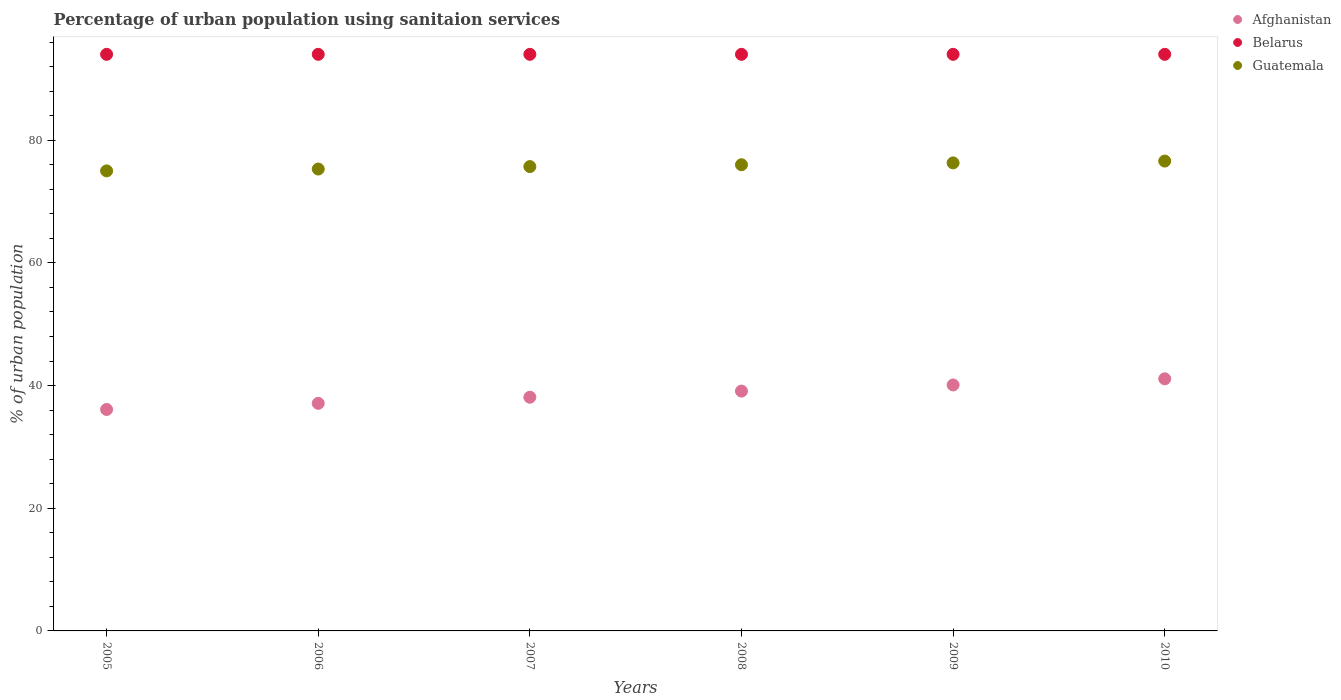How many different coloured dotlines are there?
Make the answer very short. 3. Is the number of dotlines equal to the number of legend labels?
Provide a short and direct response. Yes. What is the percentage of urban population using sanitaion services in Belarus in 2007?
Your response must be concise. 94. Across all years, what is the maximum percentage of urban population using sanitaion services in Guatemala?
Ensure brevity in your answer.  76.6. Across all years, what is the minimum percentage of urban population using sanitaion services in Belarus?
Make the answer very short. 94. What is the total percentage of urban population using sanitaion services in Belarus in the graph?
Give a very brief answer. 564. What is the difference between the percentage of urban population using sanitaion services in Belarus in 2007 and that in 2008?
Ensure brevity in your answer.  0. What is the difference between the percentage of urban population using sanitaion services in Belarus in 2006 and the percentage of urban population using sanitaion services in Afghanistan in 2010?
Make the answer very short. 52.9. What is the average percentage of urban population using sanitaion services in Afghanistan per year?
Ensure brevity in your answer.  38.6. In the year 2008, what is the difference between the percentage of urban population using sanitaion services in Belarus and percentage of urban population using sanitaion services in Afghanistan?
Ensure brevity in your answer.  54.9. In how many years, is the percentage of urban population using sanitaion services in Belarus greater than 92 %?
Keep it short and to the point. 6. What is the ratio of the percentage of urban population using sanitaion services in Belarus in 2009 to that in 2010?
Your response must be concise. 1. Is the percentage of urban population using sanitaion services in Guatemala in 2008 less than that in 2009?
Make the answer very short. Yes. What is the difference between the highest and the second highest percentage of urban population using sanitaion services in Guatemala?
Provide a short and direct response. 0.3. What is the difference between the highest and the lowest percentage of urban population using sanitaion services in Belarus?
Your response must be concise. 0. Is the sum of the percentage of urban population using sanitaion services in Belarus in 2005 and 2006 greater than the maximum percentage of urban population using sanitaion services in Afghanistan across all years?
Your answer should be very brief. Yes. Is it the case that in every year, the sum of the percentage of urban population using sanitaion services in Guatemala and percentage of urban population using sanitaion services in Belarus  is greater than the percentage of urban population using sanitaion services in Afghanistan?
Make the answer very short. Yes. Is the percentage of urban population using sanitaion services in Afghanistan strictly greater than the percentage of urban population using sanitaion services in Belarus over the years?
Offer a terse response. No. How many years are there in the graph?
Ensure brevity in your answer.  6. What is the difference between two consecutive major ticks on the Y-axis?
Provide a succinct answer. 20. Are the values on the major ticks of Y-axis written in scientific E-notation?
Your answer should be very brief. No. Does the graph contain grids?
Give a very brief answer. No. What is the title of the graph?
Offer a terse response. Percentage of urban population using sanitaion services. Does "Tonga" appear as one of the legend labels in the graph?
Offer a very short reply. No. What is the label or title of the X-axis?
Provide a short and direct response. Years. What is the label or title of the Y-axis?
Ensure brevity in your answer.  % of urban population. What is the % of urban population in Afghanistan in 2005?
Your answer should be compact. 36.1. What is the % of urban population of Belarus in 2005?
Offer a very short reply. 94. What is the % of urban population of Guatemala in 2005?
Make the answer very short. 75. What is the % of urban population in Afghanistan in 2006?
Your response must be concise. 37.1. What is the % of urban population in Belarus in 2006?
Ensure brevity in your answer.  94. What is the % of urban population of Guatemala in 2006?
Provide a short and direct response. 75.3. What is the % of urban population in Afghanistan in 2007?
Ensure brevity in your answer.  38.1. What is the % of urban population of Belarus in 2007?
Make the answer very short. 94. What is the % of urban population of Guatemala in 2007?
Offer a very short reply. 75.7. What is the % of urban population of Afghanistan in 2008?
Offer a terse response. 39.1. What is the % of urban population of Belarus in 2008?
Offer a very short reply. 94. What is the % of urban population in Guatemala in 2008?
Provide a succinct answer. 76. What is the % of urban population of Afghanistan in 2009?
Your answer should be very brief. 40.1. What is the % of urban population of Belarus in 2009?
Make the answer very short. 94. What is the % of urban population in Guatemala in 2009?
Your answer should be compact. 76.3. What is the % of urban population of Afghanistan in 2010?
Your response must be concise. 41.1. What is the % of urban population in Belarus in 2010?
Keep it short and to the point. 94. What is the % of urban population of Guatemala in 2010?
Your answer should be very brief. 76.6. Across all years, what is the maximum % of urban population of Afghanistan?
Give a very brief answer. 41.1. Across all years, what is the maximum % of urban population of Belarus?
Provide a short and direct response. 94. Across all years, what is the maximum % of urban population of Guatemala?
Ensure brevity in your answer.  76.6. Across all years, what is the minimum % of urban population of Afghanistan?
Provide a succinct answer. 36.1. Across all years, what is the minimum % of urban population in Belarus?
Provide a short and direct response. 94. Across all years, what is the minimum % of urban population in Guatemala?
Your answer should be compact. 75. What is the total % of urban population of Afghanistan in the graph?
Your answer should be compact. 231.6. What is the total % of urban population of Belarus in the graph?
Provide a succinct answer. 564. What is the total % of urban population in Guatemala in the graph?
Provide a succinct answer. 454.9. What is the difference between the % of urban population of Belarus in 2005 and that in 2006?
Ensure brevity in your answer.  0. What is the difference between the % of urban population in Guatemala in 2005 and that in 2006?
Your answer should be very brief. -0.3. What is the difference between the % of urban population in Afghanistan in 2005 and that in 2007?
Provide a short and direct response. -2. What is the difference between the % of urban population in Belarus in 2005 and that in 2007?
Offer a very short reply. 0. What is the difference between the % of urban population in Afghanistan in 2005 and that in 2008?
Offer a very short reply. -3. What is the difference between the % of urban population in Belarus in 2005 and that in 2008?
Offer a terse response. 0. What is the difference between the % of urban population of Guatemala in 2005 and that in 2008?
Offer a terse response. -1. What is the difference between the % of urban population in Guatemala in 2005 and that in 2009?
Offer a terse response. -1.3. What is the difference between the % of urban population of Afghanistan in 2005 and that in 2010?
Provide a short and direct response. -5. What is the difference between the % of urban population in Guatemala in 2005 and that in 2010?
Make the answer very short. -1.6. What is the difference between the % of urban population of Afghanistan in 2006 and that in 2007?
Offer a terse response. -1. What is the difference between the % of urban population in Belarus in 2006 and that in 2008?
Your answer should be compact. 0. What is the difference between the % of urban population in Afghanistan in 2006 and that in 2009?
Your response must be concise. -3. What is the difference between the % of urban population of Belarus in 2006 and that in 2009?
Your response must be concise. 0. What is the difference between the % of urban population in Guatemala in 2006 and that in 2009?
Offer a terse response. -1. What is the difference between the % of urban population of Afghanistan in 2006 and that in 2010?
Offer a terse response. -4. What is the difference between the % of urban population in Belarus in 2006 and that in 2010?
Provide a succinct answer. 0. What is the difference between the % of urban population of Belarus in 2007 and that in 2008?
Your answer should be compact. 0. What is the difference between the % of urban population in Belarus in 2007 and that in 2009?
Provide a succinct answer. 0. What is the difference between the % of urban population in Guatemala in 2007 and that in 2009?
Provide a succinct answer. -0.6. What is the difference between the % of urban population of Afghanistan in 2007 and that in 2010?
Your answer should be compact. -3. What is the difference between the % of urban population of Belarus in 2007 and that in 2010?
Provide a succinct answer. 0. What is the difference between the % of urban population in Belarus in 2008 and that in 2009?
Offer a terse response. 0. What is the difference between the % of urban population in Guatemala in 2008 and that in 2009?
Offer a very short reply. -0.3. What is the difference between the % of urban population of Belarus in 2008 and that in 2010?
Provide a short and direct response. 0. What is the difference between the % of urban population of Afghanistan in 2005 and the % of urban population of Belarus in 2006?
Give a very brief answer. -57.9. What is the difference between the % of urban population of Afghanistan in 2005 and the % of urban population of Guatemala in 2006?
Your answer should be compact. -39.2. What is the difference between the % of urban population of Belarus in 2005 and the % of urban population of Guatemala in 2006?
Provide a short and direct response. 18.7. What is the difference between the % of urban population in Afghanistan in 2005 and the % of urban population in Belarus in 2007?
Your answer should be very brief. -57.9. What is the difference between the % of urban population of Afghanistan in 2005 and the % of urban population of Guatemala in 2007?
Provide a short and direct response. -39.6. What is the difference between the % of urban population of Afghanistan in 2005 and the % of urban population of Belarus in 2008?
Your answer should be very brief. -57.9. What is the difference between the % of urban population of Afghanistan in 2005 and the % of urban population of Guatemala in 2008?
Provide a short and direct response. -39.9. What is the difference between the % of urban population of Belarus in 2005 and the % of urban population of Guatemala in 2008?
Give a very brief answer. 18. What is the difference between the % of urban population of Afghanistan in 2005 and the % of urban population of Belarus in 2009?
Provide a succinct answer. -57.9. What is the difference between the % of urban population in Afghanistan in 2005 and the % of urban population in Guatemala in 2009?
Provide a short and direct response. -40.2. What is the difference between the % of urban population of Belarus in 2005 and the % of urban population of Guatemala in 2009?
Give a very brief answer. 17.7. What is the difference between the % of urban population of Afghanistan in 2005 and the % of urban population of Belarus in 2010?
Ensure brevity in your answer.  -57.9. What is the difference between the % of urban population of Afghanistan in 2005 and the % of urban population of Guatemala in 2010?
Offer a terse response. -40.5. What is the difference between the % of urban population in Belarus in 2005 and the % of urban population in Guatemala in 2010?
Give a very brief answer. 17.4. What is the difference between the % of urban population of Afghanistan in 2006 and the % of urban population of Belarus in 2007?
Your response must be concise. -56.9. What is the difference between the % of urban population of Afghanistan in 2006 and the % of urban population of Guatemala in 2007?
Make the answer very short. -38.6. What is the difference between the % of urban population in Belarus in 2006 and the % of urban population in Guatemala in 2007?
Your response must be concise. 18.3. What is the difference between the % of urban population in Afghanistan in 2006 and the % of urban population in Belarus in 2008?
Give a very brief answer. -56.9. What is the difference between the % of urban population of Afghanistan in 2006 and the % of urban population of Guatemala in 2008?
Keep it short and to the point. -38.9. What is the difference between the % of urban population of Belarus in 2006 and the % of urban population of Guatemala in 2008?
Your response must be concise. 18. What is the difference between the % of urban population of Afghanistan in 2006 and the % of urban population of Belarus in 2009?
Provide a succinct answer. -56.9. What is the difference between the % of urban population in Afghanistan in 2006 and the % of urban population in Guatemala in 2009?
Offer a terse response. -39.2. What is the difference between the % of urban population of Belarus in 2006 and the % of urban population of Guatemala in 2009?
Your response must be concise. 17.7. What is the difference between the % of urban population in Afghanistan in 2006 and the % of urban population in Belarus in 2010?
Your answer should be very brief. -56.9. What is the difference between the % of urban population of Afghanistan in 2006 and the % of urban population of Guatemala in 2010?
Your answer should be very brief. -39.5. What is the difference between the % of urban population in Belarus in 2006 and the % of urban population in Guatemala in 2010?
Provide a succinct answer. 17.4. What is the difference between the % of urban population in Afghanistan in 2007 and the % of urban population in Belarus in 2008?
Provide a short and direct response. -55.9. What is the difference between the % of urban population in Afghanistan in 2007 and the % of urban population in Guatemala in 2008?
Your answer should be compact. -37.9. What is the difference between the % of urban population of Belarus in 2007 and the % of urban population of Guatemala in 2008?
Ensure brevity in your answer.  18. What is the difference between the % of urban population in Afghanistan in 2007 and the % of urban population in Belarus in 2009?
Provide a succinct answer. -55.9. What is the difference between the % of urban population in Afghanistan in 2007 and the % of urban population in Guatemala in 2009?
Ensure brevity in your answer.  -38.2. What is the difference between the % of urban population of Afghanistan in 2007 and the % of urban population of Belarus in 2010?
Offer a very short reply. -55.9. What is the difference between the % of urban population in Afghanistan in 2007 and the % of urban population in Guatemala in 2010?
Make the answer very short. -38.5. What is the difference between the % of urban population in Afghanistan in 2008 and the % of urban population in Belarus in 2009?
Your response must be concise. -54.9. What is the difference between the % of urban population of Afghanistan in 2008 and the % of urban population of Guatemala in 2009?
Ensure brevity in your answer.  -37.2. What is the difference between the % of urban population in Belarus in 2008 and the % of urban population in Guatemala in 2009?
Make the answer very short. 17.7. What is the difference between the % of urban population of Afghanistan in 2008 and the % of urban population of Belarus in 2010?
Offer a terse response. -54.9. What is the difference between the % of urban population of Afghanistan in 2008 and the % of urban population of Guatemala in 2010?
Your answer should be compact. -37.5. What is the difference between the % of urban population of Afghanistan in 2009 and the % of urban population of Belarus in 2010?
Offer a very short reply. -53.9. What is the difference between the % of urban population in Afghanistan in 2009 and the % of urban population in Guatemala in 2010?
Provide a succinct answer. -36.5. What is the difference between the % of urban population in Belarus in 2009 and the % of urban population in Guatemala in 2010?
Make the answer very short. 17.4. What is the average % of urban population of Afghanistan per year?
Offer a very short reply. 38.6. What is the average % of urban population in Belarus per year?
Your answer should be very brief. 94. What is the average % of urban population of Guatemala per year?
Give a very brief answer. 75.82. In the year 2005, what is the difference between the % of urban population of Afghanistan and % of urban population of Belarus?
Provide a short and direct response. -57.9. In the year 2005, what is the difference between the % of urban population in Afghanistan and % of urban population in Guatemala?
Your response must be concise. -38.9. In the year 2005, what is the difference between the % of urban population of Belarus and % of urban population of Guatemala?
Provide a short and direct response. 19. In the year 2006, what is the difference between the % of urban population in Afghanistan and % of urban population in Belarus?
Your answer should be very brief. -56.9. In the year 2006, what is the difference between the % of urban population of Afghanistan and % of urban population of Guatemala?
Make the answer very short. -38.2. In the year 2007, what is the difference between the % of urban population of Afghanistan and % of urban population of Belarus?
Your response must be concise. -55.9. In the year 2007, what is the difference between the % of urban population of Afghanistan and % of urban population of Guatemala?
Your response must be concise. -37.6. In the year 2007, what is the difference between the % of urban population in Belarus and % of urban population in Guatemala?
Your answer should be compact. 18.3. In the year 2008, what is the difference between the % of urban population of Afghanistan and % of urban population of Belarus?
Your answer should be compact. -54.9. In the year 2008, what is the difference between the % of urban population in Afghanistan and % of urban population in Guatemala?
Your answer should be compact. -36.9. In the year 2009, what is the difference between the % of urban population in Afghanistan and % of urban population in Belarus?
Offer a very short reply. -53.9. In the year 2009, what is the difference between the % of urban population in Afghanistan and % of urban population in Guatemala?
Provide a succinct answer. -36.2. In the year 2010, what is the difference between the % of urban population of Afghanistan and % of urban population of Belarus?
Provide a short and direct response. -52.9. In the year 2010, what is the difference between the % of urban population in Afghanistan and % of urban population in Guatemala?
Offer a terse response. -35.5. In the year 2010, what is the difference between the % of urban population of Belarus and % of urban population of Guatemala?
Your answer should be compact. 17.4. What is the ratio of the % of urban population in Belarus in 2005 to that in 2006?
Your answer should be very brief. 1. What is the ratio of the % of urban population in Guatemala in 2005 to that in 2006?
Your response must be concise. 1. What is the ratio of the % of urban population in Afghanistan in 2005 to that in 2007?
Ensure brevity in your answer.  0.95. What is the ratio of the % of urban population in Belarus in 2005 to that in 2007?
Provide a succinct answer. 1. What is the ratio of the % of urban population of Afghanistan in 2005 to that in 2008?
Your answer should be very brief. 0.92. What is the ratio of the % of urban population in Guatemala in 2005 to that in 2008?
Offer a terse response. 0.99. What is the ratio of the % of urban population in Afghanistan in 2005 to that in 2009?
Provide a succinct answer. 0.9. What is the ratio of the % of urban population in Belarus in 2005 to that in 2009?
Your answer should be compact. 1. What is the ratio of the % of urban population in Afghanistan in 2005 to that in 2010?
Offer a terse response. 0.88. What is the ratio of the % of urban population in Guatemala in 2005 to that in 2010?
Your answer should be very brief. 0.98. What is the ratio of the % of urban population of Afghanistan in 2006 to that in 2007?
Give a very brief answer. 0.97. What is the ratio of the % of urban population of Belarus in 2006 to that in 2007?
Provide a short and direct response. 1. What is the ratio of the % of urban population in Afghanistan in 2006 to that in 2008?
Provide a short and direct response. 0.95. What is the ratio of the % of urban population of Afghanistan in 2006 to that in 2009?
Ensure brevity in your answer.  0.93. What is the ratio of the % of urban population of Belarus in 2006 to that in 2009?
Keep it short and to the point. 1. What is the ratio of the % of urban population of Guatemala in 2006 to that in 2009?
Keep it short and to the point. 0.99. What is the ratio of the % of urban population in Afghanistan in 2006 to that in 2010?
Your response must be concise. 0.9. What is the ratio of the % of urban population of Belarus in 2006 to that in 2010?
Your response must be concise. 1. What is the ratio of the % of urban population in Guatemala in 2006 to that in 2010?
Your answer should be compact. 0.98. What is the ratio of the % of urban population of Afghanistan in 2007 to that in 2008?
Ensure brevity in your answer.  0.97. What is the ratio of the % of urban population in Belarus in 2007 to that in 2008?
Your answer should be very brief. 1. What is the ratio of the % of urban population of Guatemala in 2007 to that in 2008?
Provide a short and direct response. 1. What is the ratio of the % of urban population in Afghanistan in 2007 to that in 2009?
Keep it short and to the point. 0.95. What is the ratio of the % of urban population of Belarus in 2007 to that in 2009?
Provide a succinct answer. 1. What is the ratio of the % of urban population of Guatemala in 2007 to that in 2009?
Offer a terse response. 0.99. What is the ratio of the % of urban population in Afghanistan in 2007 to that in 2010?
Your answer should be compact. 0.93. What is the ratio of the % of urban population in Guatemala in 2007 to that in 2010?
Your answer should be compact. 0.99. What is the ratio of the % of urban population in Afghanistan in 2008 to that in 2009?
Provide a succinct answer. 0.98. What is the ratio of the % of urban population in Belarus in 2008 to that in 2009?
Your answer should be compact. 1. What is the ratio of the % of urban population of Afghanistan in 2008 to that in 2010?
Keep it short and to the point. 0.95. What is the ratio of the % of urban population of Afghanistan in 2009 to that in 2010?
Give a very brief answer. 0.98. What is the difference between the highest and the second highest % of urban population in Afghanistan?
Your answer should be compact. 1. What is the difference between the highest and the lowest % of urban population of Belarus?
Your response must be concise. 0. What is the difference between the highest and the lowest % of urban population in Guatemala?
Your answer should be compact. 1.6. 